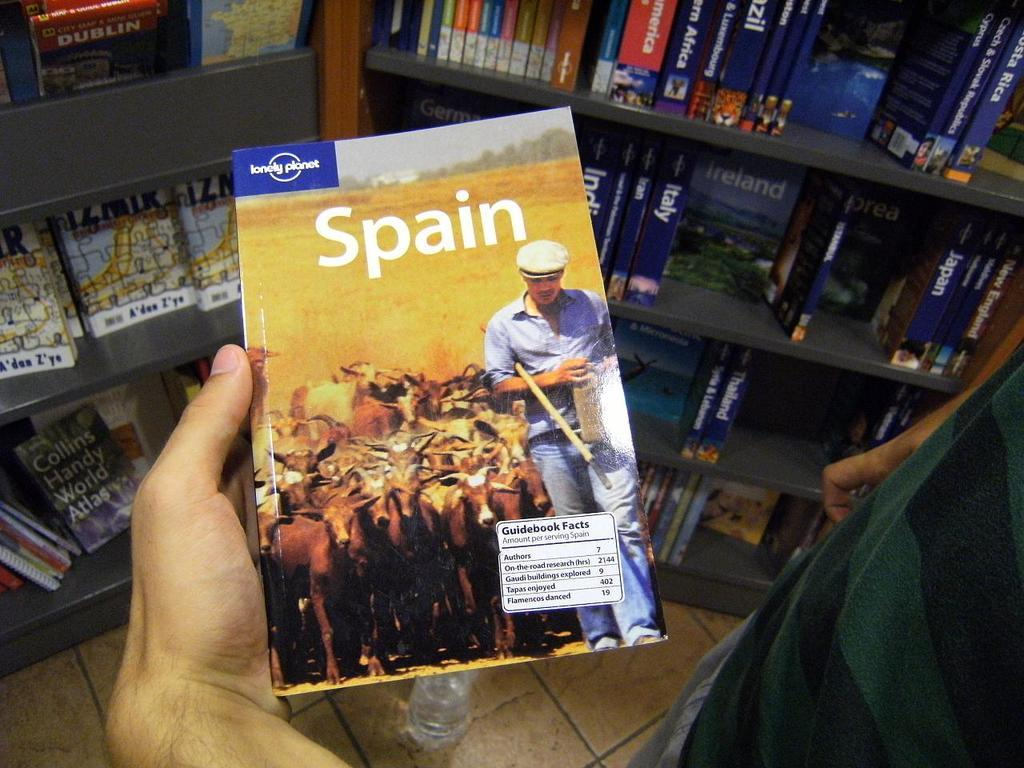<image>
Summarize the visual content of the image. A person holds a travel book about Spain in front of many other travel books on the shelves. 